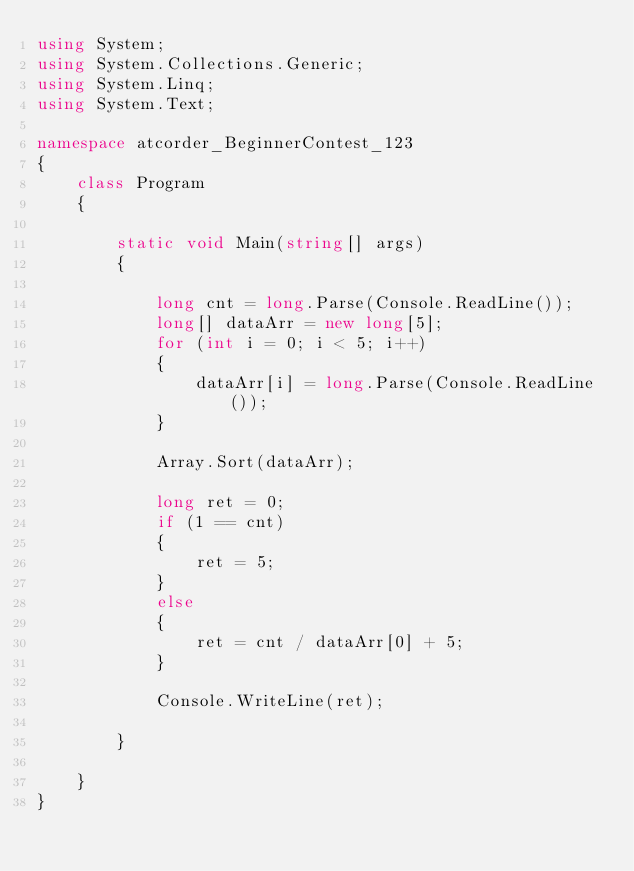Convert code to text. <code><loc_0><loc_0><loc_500><loc_500><_C#_>using System;
using System.Collections.Generic;
using System.Linq;
using System.Text;

namespace atcorder_BeginnerContest_123
{
    class Program
    {

        static void Main(string[] args)
        {

            long cnt = long.Parse(Console.ReadLine());
            long[] dataArr = new long[5];
            for (int i = 0; i < 5; i++)
            {
                dataArr[i] = long.Parse(Console.ReadLine());
            }

            Array.Sort(dataArr);

            long ret = 0;
            if (1 == cnt)
            {
                ret = 5;
            }
            else
            {
                ret = cnt / dataArr[0] + 5;
            }

            Console.WriteLine(ret);

        }

    }
}

</code> 